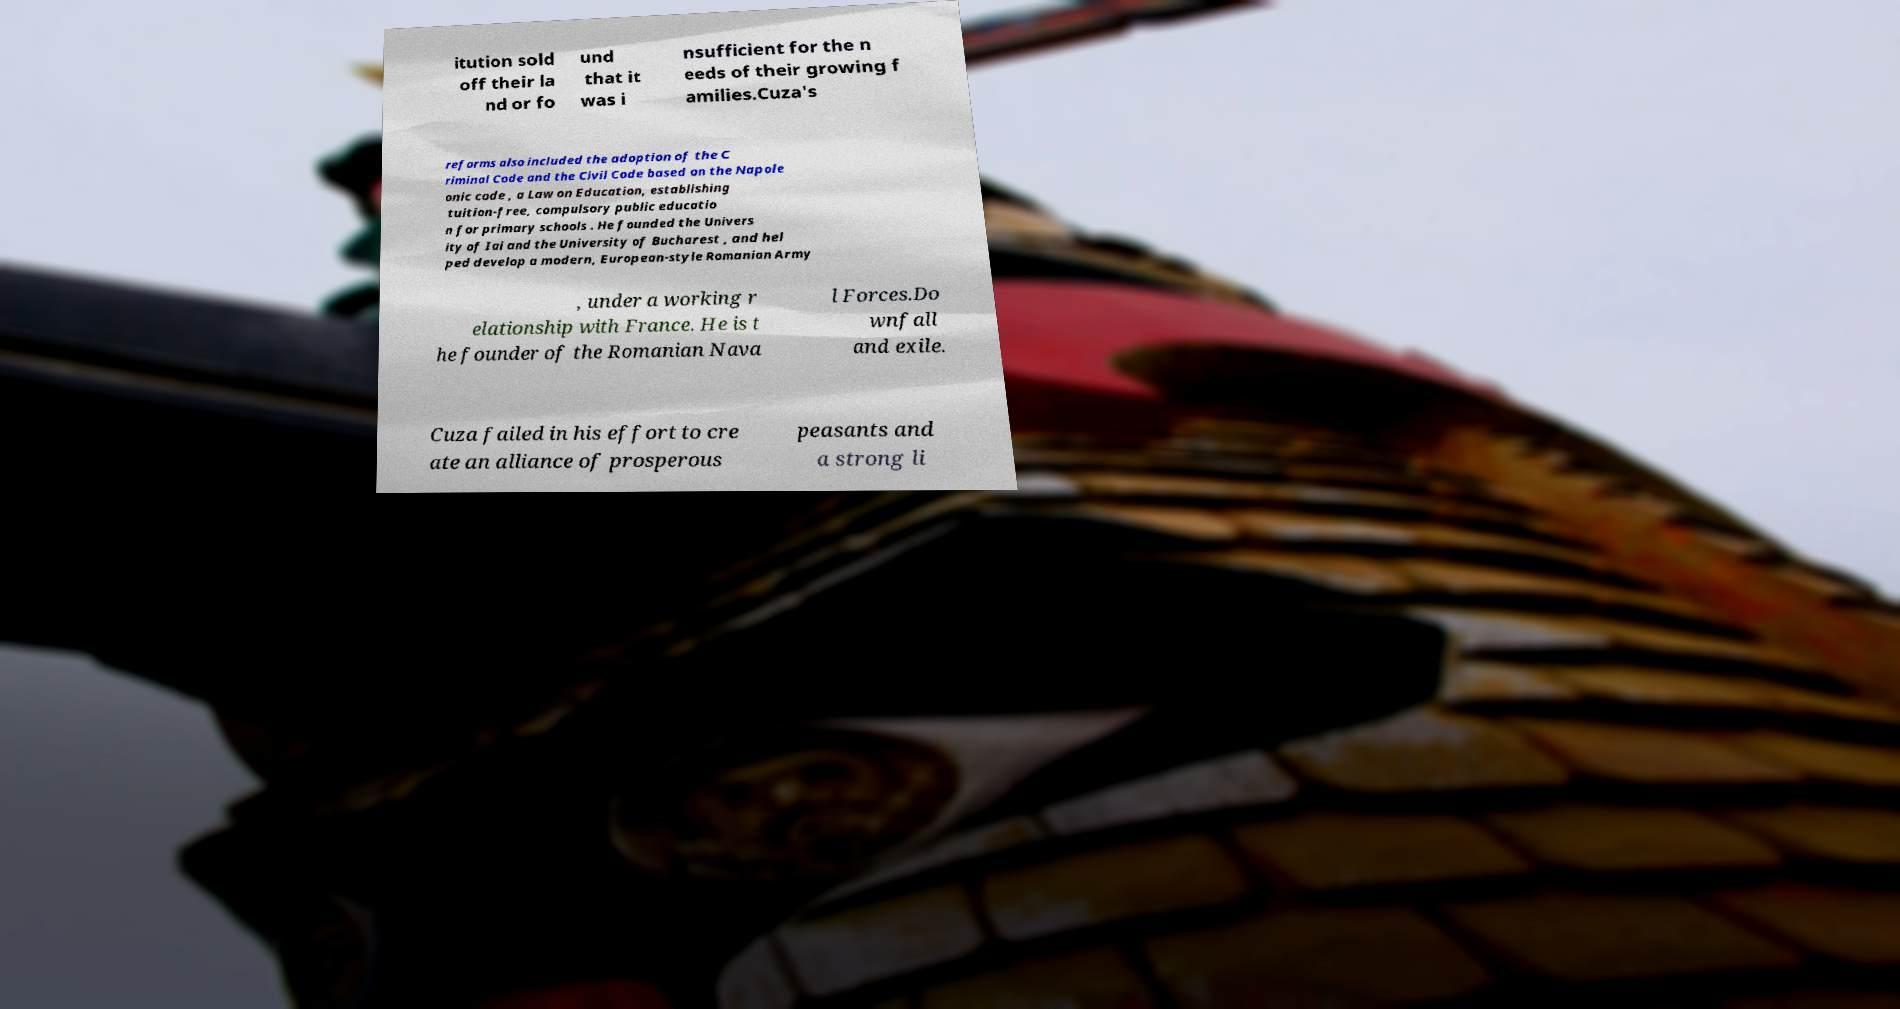Please read and relay the text visible in this image. What does it say? itution sold off their la nd or fo und that it was i nsufficient for the n eeds of their growing f amilies.Cuza's reforms also included the adoption of the C riminal Code and the Civil Code based on the Napole onic code , a Law on Education, establishing tuition-free, compulsory public educatio n for primary schools . He founded the Univers ity of Iai and the University of Bucharest , and hel ped develop a modern, European-style Romanian Army , under a working r elationship with France. He is t he founder of the Romanian Nava l Forces.Do wnfall and exile. Cuza failed in his effort to cre ate an alliance of prosperous peasants and a strong li 